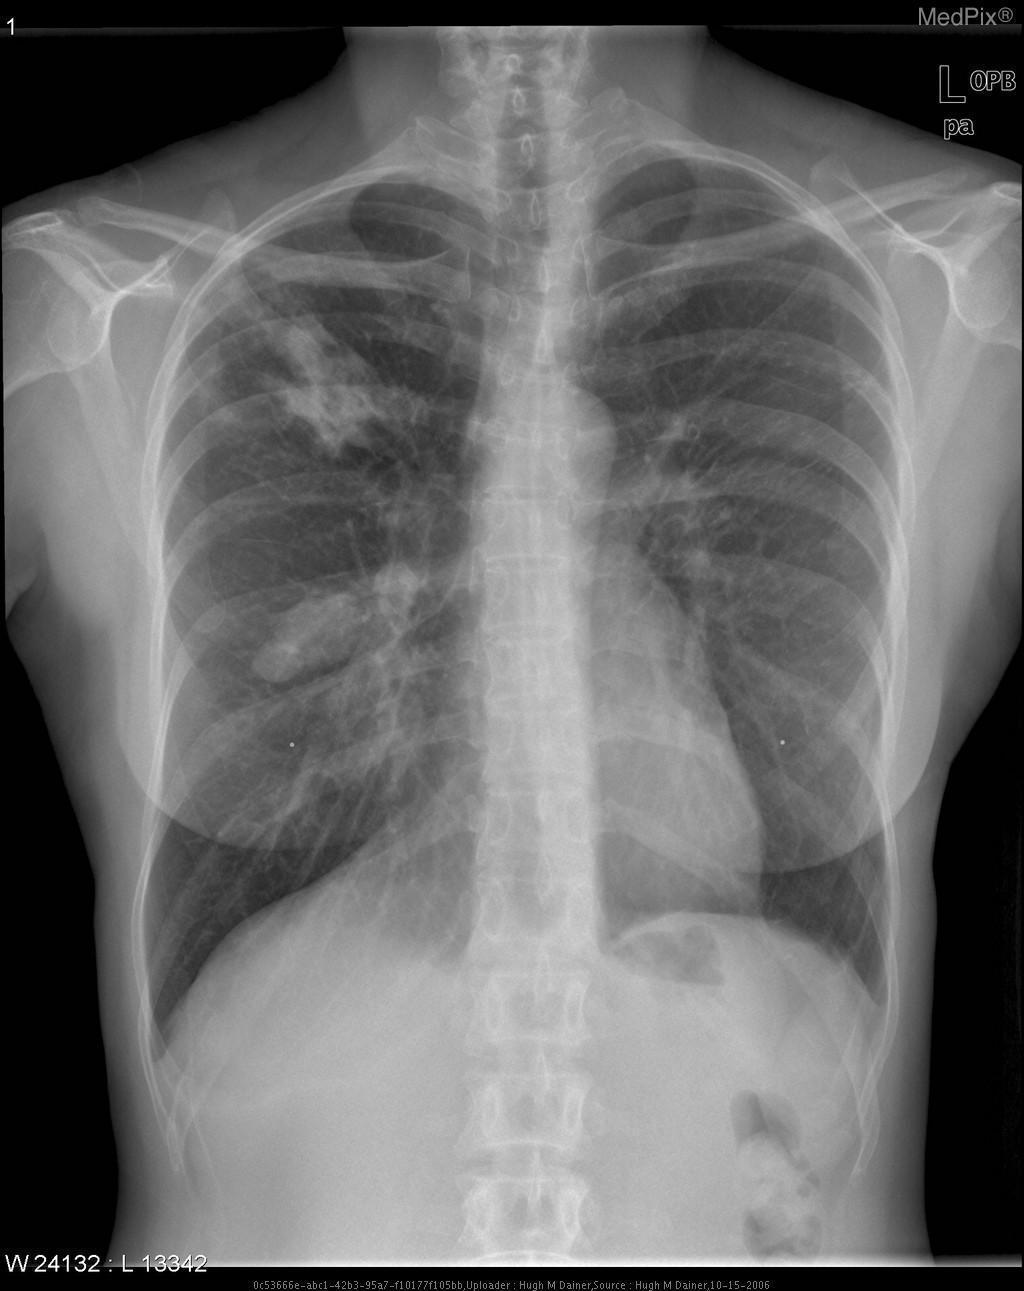Is this film properly exposed?
Quick response, please. Yes. What is the name of this image's plane?
Concise answer only. Posteroanterior. Is the right lung normal in size?
Keep it brief. No. What is happening with the path of the trachea?
Write a very short answer. It is shifted to the right. Is the stomach dilated?
Short answer required. No. How do we call these wide undulations along the vertebral column?
Keep it brief. Scoliosis. 